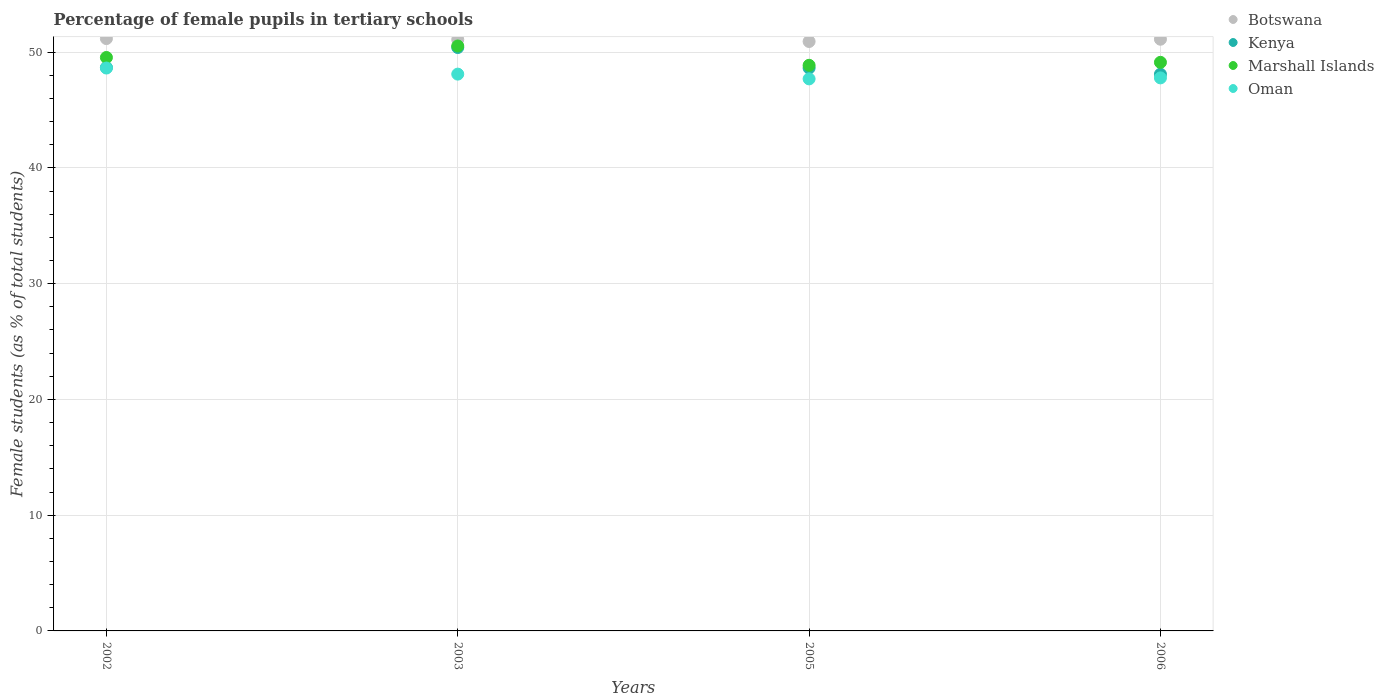How many different coloured dotlines are there?
Keep it short and to the point. 4. What is the percentage of female pupils in tertiary schools in Kenya in 2002?
Ensure brevity in your answer.  48.67. Across all years, what is the maximum percentage of female pupils in tertiary schools in Oman?
Your response must be concise. 48.62. Across all years, what is the minimum percentage of female pupils in tertiary schools in Kenya?
Offer a very short reply. 48.09. In which year was the percentage of female pupils in tertiary schools in Kenya maximum?
Provide a succinct answer. 2003. What is the total percentage of female pupils in tertiary schools in Oman in the graph?
Give a very brief answer. 192.18. What is the difference between the percentage of female pupils in tertiary schools in Oman in 2003 and that in 2006?
Provide a succinct answer. 0.32. What is the difference between the percentage of female pupils in tertiary schools in Oman in 2003 and the percentage of female pupils in tertiary schools in Marshall Islands in 2005?
Ensure brevity in your answer.  -0.76. What is the average percentage of female pupils in tertiary schools in Marshall Islands per year?
Offer a very short reply. 49.51. In the year 2005, what is the difference between the percentage of female pupils in tertiary schools in Botswana and percentage of female pupils in tertiary schools in Kenya?
Ensure brevity in your answer.  2.29. In how many years, is the percentage of female pupils in tertiary schools in Marshall Islands greater than 32 %?
Make the answer very short. 4. What is the ratio of the percentage of female pupils in tertiary schools in Botswana in 2005 to that in 2006?
Offer a terse response. 1. Is the percentage of female pupils in tertiary schools in Oman in 2003 less than that in 2005?
Offer a terse response. No. What is the difference between the highest and the second highest percentage of female pupils in tertiary schools in Botswana?
Your answer should be very brief. 0.06. What is the difference between the highest and the lowest percentage of female pupils in tertiary schools in Kenya?
Your response must be concise. 2.31. In how many years, is the percentage of female pupils in tertiary schools in Marshall Islands greater than the average percentage of female pupils in tertiary schools in Marshall Islands taken over all years?
Provide a short and direct response. 2. Is it the case that in every year, the sum of the percentage of female pupils in tertiary schools in Botswana and percentage of female pupils in tertiary schools in Kenya  is greater than the sum of percentage of female pupils in tertiary schools in Marshall Islands and percentage of female pupils in tertiary schools in Oman?
Provide a short and direct response. Yes. Is the percentage of female pupils in tertiary schools in Marshall Islands strictly greater than the percentage of female pupils in tertiary schools in Oman over the years?
Ensure brevity in your answer.  Yes. Is the percentage of female pupils in tertiary schools in Kenya strictly less than the percentage of female pupils in tertiary schools in Oman over the years?
Your answer should be very brief. No. What is the difference between two consecutive major ticks on the Y-axis?
Offer a very short reply. 10. Does the graph contain any zero values?
Offer a terse response. No. Where does the legend appear in the graph?
Your answer should be compact. Top right. How are the legend labels stacked?
Your answer should be compact. Vertical. What is the title of the graph?
Give a very brief answer. Percentage of female pupils in tertiary schools. What is the label or title of the X-axis?
Offer a very short reply. Years. What is the label or title of the Y-axis?
Your answer should be very brief. Female students (as % of total students). What is the Female students (as % of total students) of Botswana in 2002?
Keep it short and to the point. 51.17. What is the Female students (as % of total students) of Kenya in 2002?
Your answer should be compact. 48.67. What is the Female students (as % of total students) of Marshall Islands in 2002?
Offer a very short reply. 49.54. What is the Female students (as % of total students) in Oman in 2002?
Ensure brevity in your answer.  48.62. What is the Female students (as % of total students) of Botswana in 2003?
Your response must be concise. 51.09. What is the Female students (as % of total students) in Kenya in 2003?
Offer a very short reply. 50.4. What is the Female students (as % of total students) in Marshall Islands in 2003?
Your answer should be compact. 50.53. What is the Female students (as % of total students) in Oman in 2003?
Provide a short and direct response. 48.1. What is the Female students (as % of total students) of Botswana in 2005?
Offer a terse response. 50.92. What is the Female students (as % of total students) in Kenya in 2005?
Offer a terse response. 48.62. What is the Female students (as % of total students) of Marshall Islands in 2005?
Your response must be concise. 48.86. What is the Female students (as % of total students) in Oman in 2005?
Give a very brief answer. 47.69. What is the Female students (as % of total students) in Botswana in 2006?
Your answer should be compact. 51.11. What is the Female students (as % of total students) of Kenya in 2006?
Your answer should be very brief. 48.09. What is the Female students (as % of total students) in Marshall Islands in 2006?
Make the answer very short. 49.12. What is the Female students (as % of total students) of Oman in 2006?
Provide a short and direct response. 47.77. Across all years, what is the maximum Female students (as % of total students) of Botswana?
Offer a very short reply. 51.17. Across all years, what is the maximum Female students (as % of total students) in Kenya?
Your answer should be compact. 50.4. Across all years, what is the maximum Female students (as % of total students) in Marshall Islands?
Keep it short and to the point. 50.53. Across all years, what is the maximum Female students (as % of total students) in Oman?
Your response must be concise. 48.62. Across all years, what is the minimum Female students (as % of total students) in Botswana?
Give a very brief answer. 50.92. Across all years, what is the minimum Female students (as % of total students) in Kenya?
Keep it short and to the point. 48.09. Across all years, what is the minimum Female students (as % of total students) of Marshall Islands?
Your response must be concise. 48.86. Across all years, what is the minimum Female students (as % of total students) in Oman?
Provide a short and direct response. 47.69. What is the total Female students (as % of total students) of Botswana in the graph?
Your response must be concise. 204.28. What is the total Female students (as % of total students) in Kenya in the graph?
Your answer should be compact. 195.77. What is the total Female students (as % of total students) of Marshall Islands in the graph?
Offer a terse response. 198.04. What is the total Female students (as % of total students) in Oman in the graph?
Your answer should be compact. 192.18. What is the difference between the Female students (as % of total students) in Botswana in 2002 and that in 2003?
Your response must be concise. 0.08. What is the difference between the Female students (as % of total students) of Kenya in 2002 and that in 2003?
Offer a very short reply. -1.73. What is the difference between the Female students (as % of total students) of Marshall Islands in 2002 and that in 2003?
Your answer should be very brief. -0.99. What is the difference between the Female students (as % of total students) in Oman in 2002 and that in 2003?
Make the answer very short. 0.53. What is the difference between the Female students (as % of total students) of Botswana in 2002 and that in 2005?
Your response must be concise. 0.25. What is the difference between the Female students (as % of total students) in Kenya in 2002 and that in 2005?
Your response must be concise. 0.05. What is the difference between the Female students (as % of total students) in Marshall Islands in 2002 and that in 2005?
Your response must be concise. 0.68. What is the difference between the Female students (as % of total students) of Oman in 2002 and that in 2005?
Make the answer very short. 0.94. What is the difference between the Female students (as % of total students) in Botswana in 2002 and that in 2006?
Offer a very short reply. 0.06. What is the difference between the Female students (as % of total students) of Kenya in 2002 and that in 2006?
Provide a short and direct response. 0.58. What is the difference between the Female students (as % of total students) of Marshall Islands in 2002 and that in 2006?
Ensure brevity in your answer.  0.42. What is the difference between the Female students (as % of total students) of Oman in 2002 and that in 2006?
Your response must be concise. 0.85. What is the difference between the Female students (as % of total students) of Botswana in 2003 and that in 2005?
Make the answer very short. 0.17. What is the difference between the Female students (as % of total students) of Kenya in 2003 and that in 2005?
Offer a terse response. 1.77. What is the difference between the Female students (as % of total students) of Marshall Islands in 2003 and that in 2005?
Provide a succinct answer. 1.67. What is the difference between the Female students (as % of total students) of Oman in 2003 and that in 2005?
Your response must be concise. 0.41. What is the difference between the Female students (as % of total students) in Botswana in 2003 and that in 2006?
Keep it short and to the point. -0.02. What is the difference between the Female students (as % of total students) in Kenya in 2003 and that in 2006?
Offer a very short reply. 2.31. What is the difference between the Female students (as % of total students) of Marshall Islands in 2003 and that in 2006?
Make the answer very short. 1.41. What is the difference between the Female students (as % of total students) of Oman in 2003 and that in 2006?
Make the answer very short. 0.32. What is the difference between the Female students (as % of total students) in Botswana in 2005 and that in 2006?
Provide a short and direct response. -0.2. What is the difference between the Female students (as % of total students) in Kenya in 2005 and that in 2006?
Ensure brevity in your answer.  0.53. What is the difference between the Female students (as % of total students) in Marshall Islands in 2005 and that in 2006?
Your answer should be very brief. -0.26. What is the difference between the Female students (as % of total students) in Oman in 2005 and that in 2006?
Keep it short and to the point. -0.09. What is the difference between the Female students (as % of total students) of Botswana in 2002 and the Female students (as % of total students) of Kenya in 2003?
Provide a short and direct response. 0.77. What is the difference between the Female students (as % of total students) in Botswana in 2002 and the Female students (as % of total students) in Marshall Islands in 2003?
Offer a terse response. 0.64. What is the difference between the Female students (as % of total students) of Botswana in 2002 and the Female students (as % of total students) of Oman in 2003?
Your answer should be very brief. 3.07. What is the difference between the Female students (as % of total students) in Kenya in 2002 and the Female students (as % of total students) in Marshall Islands in 2003?
Your answer should be compact. -1.86. What is the difference between the Female students (as % of total students) in Kenya in 2002 and the Female students (as % of total students) in Oman in 2003?
Your answer should be very brief. 0.57. What is the difference between the Female students (as % of total students) of Marshall Islands in 2002 and the Female students (as % of total students) of Oman in 2003?
Give a very brief answer. 1.44. What is the difference between the Female students (as % of total students) of Botswana in 2002 and the Female students (as % of total students) of Kenya in 2005?
Provide a short and direct response. 2.55. What is the difference between the Female students (as % of total students) in Botswana in 2002 and the Female students (as % of total students) in Marshall Islands in 2005?
Provide a short and direct response. 2.31. What is the difference between the Female students (as % of total students) of Botswana in 2002 and the Female students (as % of total students) of Oman in 2005?
Make the answer very short. 3.48. What is the difference between the Female students (as % of total students) in Kenya in 2002 and the Female students (as % of total students) in Marshall Islands in 2005?
Keep it short and to the point. -0.19. What is the difference between the Female students (as % of total students) in Kenya in 2002 and the Female students (as % of total students) in Oman in 2005?
Provide a succinct answer. 0.98. What is the difference between the Female students (as % of total students) of Marshall Islands in 2002 and the Female students (as % of total students) of Oman in 2005?
Provide a short and direct response. 1.85. What is the difference between the Female students (as % of total students) in Botswana in 2002 and the Female students (as % of total students) in Kenya in 2006?
Make the answer very short. 3.08. What is the difference between the Female students (as % of total students) of Botswana in 2002 and the Female students (as % of total students) of Marshall Islands in 2006?
Ensure brevity in your answer.  2.05. What is the difference between the Female students (as % of total students) in Botswana in 2002 and the Female students (as % of total students) in Oman in 2006?
Provide a succinct answer. 3.39. What is the difference between the Female students (as % of total students) in Kenya in 2002 and the Female students (as % of total students) in Marshall Islands in 2006?
Provide a short and direct response. -0.45. What is the difference between the Female students (as % of total students) in Kenya in 2002 and the Female students (as % of total students) in Oman in 2006?
Keep it short and to the point. 0.9. What is the difference between the Female students (as % of total students) of Marshall Islands in 2002 and the Female students (as % of total students) of Oman in 2006?
Offer a very short reply. 1.76. What is the difference between the Female students (as % of total students) in Botswana in 2003 and the Female students (as % of total students) in Kenya in 2005?
Provide a succinct answer. 2.47. What is the difference between the Female students (as % of total students) in Botswana in 2003 and the Female students (as % of total students) in Marshall Islands in 2005?
Make the answer very short. 2.23. What is the difference between the Female students (as % of total students) of Botswana in 2003 and the Female students (as % of total students) of Oman in 2005?
Your answer should be compact. 3.4. What is the difference between the Female students (as % of total students) of Kenya in 2003 and the Female students (as % of total students) of Marshall Islands in 2005?
Your answer should be very brief. 1.54. What is the difference between the Female students (as % of total students) of Kenya in 2003 and the Female students (as % of total students) of Oman in 2005?
Ensure brevity in your answer.  2.71. What is the difference between the Female students (as % of total students) of Marshall Islands in 2003 and the Female students (as % of total students) of Oman in 2005?
Give a very brief answer. 2.84. What is the difference between the Female students (as % of total students) of Botswana in 2003 and the Female students (as % of total students) of Kenya in 2006?
Ensure brevity in your answer.  3. What is the difference between the Female students (as % of total students) of Botswana in 2003 and the Female students (as % of total students) of Marshall Islands in 2006?
Offer a terse response. 1.97. What is the difference between the Female students (as % of total students) of Botswana in 2003 and the Female students (as % of total students) of Oman in 2006?
Provide a succinct answer. 3.31. What is the difference between the Female students (as % of total students) of Kenya in 2003 and the Female students (as % of total students) of Marshall Islands in 2006?
Offer a terse response. 1.28. What is the difference between the Female students (as % of total students) in Kenya in 2003 and the Female students (as % of total students) in Oman in 2006?
Give a very brief answer. 2.62. What is the difference between the Female students (as % of total students) in Marshall Islands in 2003 and the Female students (as % of total students) in Oman in 2006?
Ensure brevity in your answer.  2.76. What is the difference between the Female students (as % of total students) in Botswana in 2005 and the Female students (as % of total students) in Kenya in 2006?
Ensure brevity in your answer.  2.83. What is the difference between the Female students (as % of total students) in Botswana in 2005 and the Female students (as % of total students) in Marshall Islands in 2006?
Offer a very short reply. 1.8. What is the difference between the Female students (as % of total students) of Botswana in 2005 and the Female students (as % of total students) of Oman in 2006?
Offer a terse response. 3.14. What is the difference between the Female students (as % of total students) in Kenya in 2005 and the Female students (as % of total students) in Marshall Islands in 2006?
Your response must be concise. -0.49. What is the difference between the Female students (as % of total students) in Kenya in 2005 and the Female students (as % of total students) in Oman in 2006?
Make the answer very short. 0.85. What is the difference between the Female students (as % of total students) in Marshall Islands in 2005 and the Female students (as % of total students) in Oman in 2006?
Keep it short and to the point. 1.09. What is the average Female students (as % of total students) of Botswana per year?
Your response must be concise. 51.07. What is the average Female students (as % of total students) of Kenya per year?
Your response must be concise. 48.94. What is the average Female students (as % of total students) of Marshall Islands per year?
Provide a short and direct response. 49.51. What is the average Female students (as % of total students) in Oman per year?
Make the answer very short. 48.04. In the year 2002, what is the difference between the Female students (as % of total students) of Botswana and Female students (as % of total students) of Kenya?
Provide a short and direct response. 2.5. In the year 2002, what is the difference between the Female students (as % of total students) in Botswana and Female students (as % of total students) in Marshall Islands?
Provide a succinct answer. 1.63. In the year 2002, what is the difference between the Female students (as % of total students) of Botswana and Female students (as % of total students) of Oman?
Keep it short and to the point. 2.54. In the year 2002, what is the difference between the Female students (as % of total students) in Kenya and Female students (as % of total students) in Marshall Islands?
Give a very brief answer. -0.87. In the year 2002, what is the difference between the Female students (as % of total students) in Kenya and Female students (as % of total students) in Oman?
Your response must be concise. 0.05. In the year 2002, what is the difference between the Female students (as % of total students) in Marshall Islands and Female students (as % of total students) in Oman?
Offer a very short reply. 0.91. In the year 2003, what is the difference between the Female students (as % of total students) of Botswana and Female students (as % of total students) of Kenya?
Offer a terse response. 0.69. In the year 2003, what is the difference between the Female students (as % of total students) in Botswana and Female students (as % of total students) in Marshall Islands?
Your response must be concise. 0.56. In the year 2003, what is the difference between the Female students (as % of total students) of Botswana and Female students (as % of total students) of Oman?
Offer a very short reply. 2.99. In the year 2003, what is the difference between the Female students (as % of total students) in Kenya and Female students (as % of total students) in Marshall Islands?
Offer a very short reply. -0.13. In the year 2003, what is the difference between the Female students (as % of total students) in Kenya and Female students (as % of total students) in Oman?
Provide a succinct answer. 2.3. In the year 2003, what is the difference between the Female students (as % of total students) in Marshall Islands and Female students (as % of total students) in Oman?
Keep it short and to the point. 2.43. In the year 2005, what is the difference between the Female students (as % of total students) in Botswana and Female students (as % of total students) in Kenya?
Make the answer very short. 2.29. In the year 2005, what is the difference between the Female students (as % of total students) of Botswana and Female students (as % of total students) of Marshall Islands?
Provide a short and direct response. 2.06. In the year 2005, what is the difference between the Female students (as % of total students) of Botswana and Female students (as % of total students) of Oman?
Ensure brevity in your answer.  3.23. In the year 2005, what is the difference between the Female students (as % of total students) of Kenya and Female students (as % of total students) of Marshall Islands?
Give a very brief answer. -0.24. In the year 2005, what is the difference between the Female students (as % of total students) in Kenya and Female students (as % of total students) in Oman?
Offer a terse response. 0.94. In the year 2005, what is the difference between the Female students (as % of total students) in Marshall Islands and Female students (as % of total students) in Oman?
Provide a succinct answer. 1.17. In the year 2006, what is the difference between the Female students (as % of total students) in Botswana and Female students (as % of total students) in Kenya?
Offer a terse response. 3.02. In the year 2006, what is the difference between the Female students (as % of total students) in Botswana and Female students (as % of total students) in Marshall Islands?
Make the answer very short. 2. In the year 2006, what is the difference between the Female students (as % of total students) of Botswana and Female students (as % of total students) of Oman?
Provide a succinct answer. 3.34. In the year 2006, what is the difference between the Female students (as % of total students) in Kenya and Female students (as % of total students) in Marshall Islands?
Offer a very short reply. -1.03. In the year 2006, what is the difference between the Female students (as % of total students) of Kenya and Female students (as % of total students) of Oman?
Your answer should be compact. 0.32. In the year 2006, what is the difference between the Female students (as % of total students) in Marshall Islands and Female students (as % of total students) in Oman?
Your answer should be compact. 1.34. What is the ratio of the Female students (as % of total students) in Kenya in 2002 to that in 2003?
Your answer should be very brief. 0.97. What is the ratio of the Female students (as % of total students) in Marshall Islands in 2002 to that in 2003?
Your response must be concise. 0.98. What is the ratio of the Female students (as % of total students) of Oman in 2002 to that in 2003?
Give a very brief answer. 1.01. What is the ratio of the Female students (as % of total students) of Botswana in 2002 to that in 2005?
Offer a terse response. 1. What is the ratio of the Female students (as % of total students) in Kenya in 2002 to that in 2005?
Your answer should be compact. 1. What is the ratio of the Female students (as % of total students) of Marshall Islands in 2002 to that in 2005?
Offer a very short reply. 1.01. What is the ratio of the Female students (as % of total students) in Oman in 2002 to that in 2005?
Give a very brief answer. 1.02. What is the ratio of the Female students (as % of total students) in Botswana in 2002 to that in 2006?
Make the answer very short. 1. What is the ratio of the Female students (as % of total students) in Marshall Islands in 2002 to that in 2006?
Offer a very short reply. 1.01. What is the ratio of the Female students (as % of total students) of Oman in 2002 to that in 2006?
Your response must be concise. 1.02. What is the ratio of the Female students (as % of total students) of Botswana in 2003 to that in 2005?
Offer a very short reply. 1. What is the ratio of the Female students (as % of total students) in Kenya in 2003 to that in 2005?
Ensure brevity in your answer.  1.04. What is the ratio of the Female students (as % of total students) in Marshall Islands in 2003 to that in 2005?
Provide a succinct answer. 1.03. What is the ratio of the Female students (as % of total students) of Oman in 2003 to that in 2005?
Keep it short and to the point. 1.01. What is the ratio of the Female students (as % of total students) in Botswana in 2003 to that in 2006?
Keep it short and to the point. 1. What is the ratio of the Female students (as % of total students) of Kenya in 2003 to that in 2006?
Provide a short and direct response. 1.05. What is the ratio of the Female students (as % of total students) of Marshall Islands in 2003 to that in 2006?
Provide a short and direct response. 1.03. What is the ratio of the Female students (as % of total students) of Oman in 2003 to that in 2006?
Offer a terse response. 1.01. What is the ratio of the Female students (as % of total students) of Botswana in 2005 to that in 2006?
Provide a succinct answer. 1. What is the ratio of the Female students (as % of total students) in Kenya in 2005 to that in 2006?
Your answer should be compact. 1.01. What is the difference between the highest and the second highest Female students (as % of total students) in Botswana?
Keep it short and to the point. 0.06. What is the difference between the highest and the second highest Female students (as % of total students) in Kenya?
Provide a short and direct response. 1.73. What is the difference between the highest and the second highest Female students (as % of total students) of Oman?
Make the answer very short. 0.53. What is the difference between the highest and the lowest Female students (as % of total students) in Botswana?
Provide a short and direct response. 0.25. What is the difference between the highest and the lowest Female students (as % of total students) in Kenya?
Keep it short and to the point. 2.31. What is the difference between the highest and the lowest Female students (as % of total students) of Marshall Islands?
Your answer should be very brief. 1.67. What is the difference between the highest and the lowest Female students (as % of total students) in Oman?
Your answer should be very brief. 0.94. 